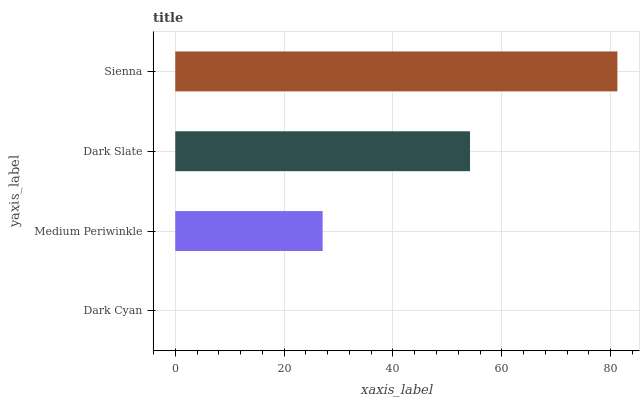Is Dark Cyan the minimum?
Answer yes or no. Yes. Is Sienna the maximum?
Answer yes or no. Yes. Is Medium Periwinkle the minimum?
Answer yes or no. No. Is Medium Periwinkle the maximum?
Answer yes or no. No. Is Medium Periwinkle greater than Dark Cyan?
Answer yes or no. Yes. Is Dark Cyan less than Medium Periwinkle?
Answer yes or no. Yes. Is Dark Cyan greater than Medium Periwinkle?
Answer yes or no. No. Is Medium Periwinkle less than Dark Cyan?
Answer yes or no. No. Is Dark Slate the high median?
Answer yes or no. Yes. Is Medium Periwinkle the low median?
Answer yes or no. Yes. Is Dark Cyan the high median?
Answer yes or no. No. Is Dark Cyan the low median?
Answer yes or no. No. 